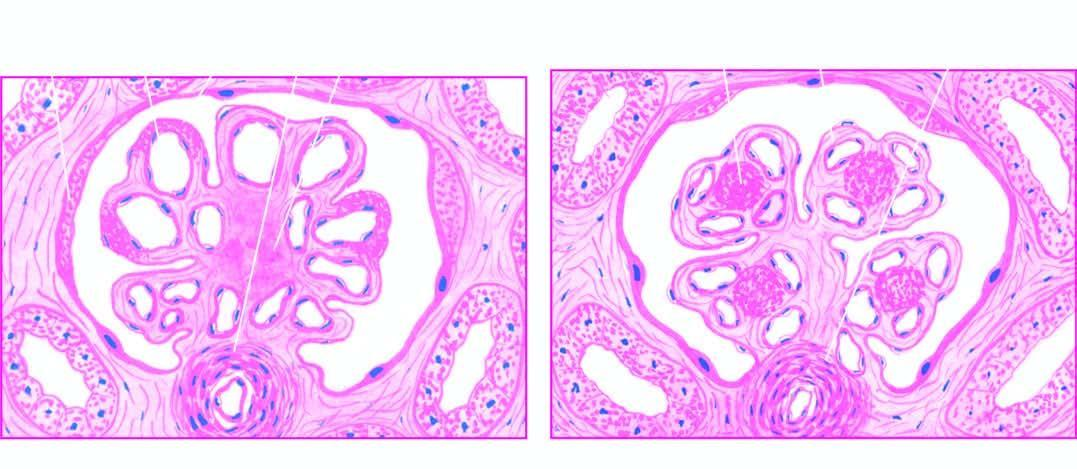where are the characteristic features?
Answer the question using a single word or phrase. In the mesangial matrix 